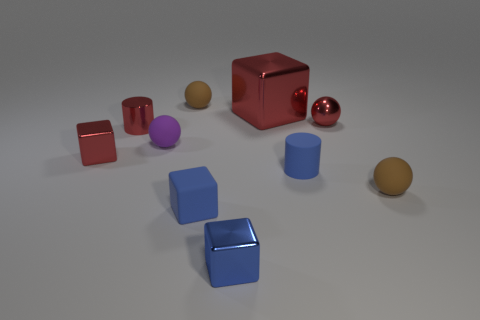Subtract all blue blocks. How many were subtracted if there are1blue blocks left? 1 Subtract all purple rubber spheres. How many spheres are left? 3 Subtract all blue cubes. How many cubes are left? 2 Subtract all cylinders. How many objects are left? 8 Subtract 2 balls. How many balls are left? 2 Subtract all gray spheres. How many blue cubes are left? 2 Subtract all large yellow metallic balls. Subtract all small red cubes. How many objects are left? 9 Add 4 tiny metallic balls. How many tiny metallic balls are left? 5 Add 8 blue shiny objects. How many blue shiny objects exist? 9 Subtract 0 gray cylinders. How many objects are left? 10 